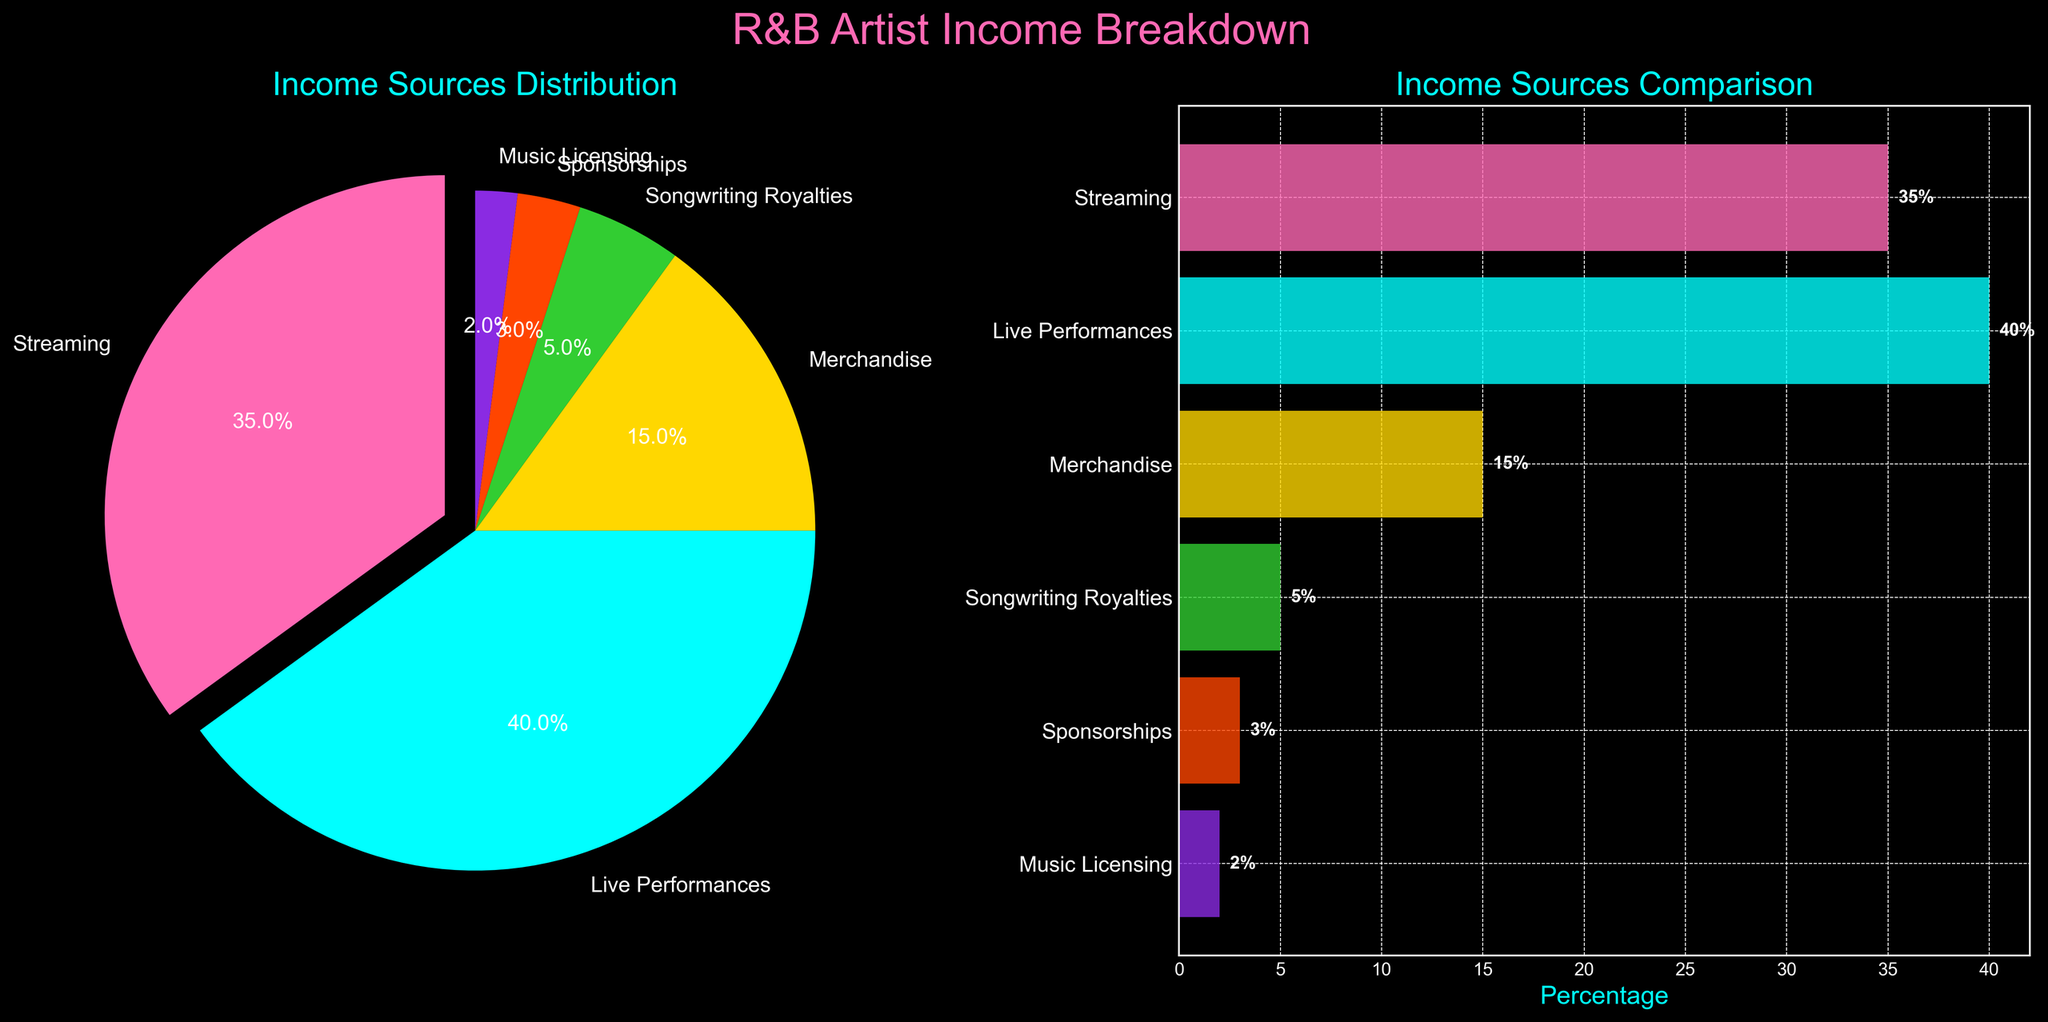What are the main income sources for R&B artists shown in the figure? The figure presents various income sources distributed in a pie chart and a horizontal bar chart. The main sources are Streaming, Live Performances, Merchandise, Songwriting Royalties, Sponsorships, and Music Licensing.
Answer: Streaming, Live Performances, Merchandise, Songwriting Royalties, Sponsorships, Music Licensing Which income source contributes the highest percentage to R&B artists' income? The pie chart and bar chart both show the highest percentage contribution from Live Performances.
Answer: Live Performances How does the income from Streaming compare to the income from Merchandise? By looking at the percentages in both charts, Streaming contributes 35%, while Merchandise contributes 15%.
Answer: Streaming is more than double Merchandise What is the combined percentage of income from Songwriting Royalties, Sponsorships, and Music Licensing? Add the percentages of these three sources: 5% (Songwriting Royalties) + 3% (Sponsorships) + 2% (Music Licensing) = 10%.
Answer: 10% Which two sources together almost equal the income from Live Performances? From the bar and pie charts, Streaming (35%) and Merchandise (15%) are closest to Live Performances (40%) when combined. Their total is 35% + 15% = 50%.
Answer: Streaming and Merchandise What percentage of income comes from sources other than Live Performances and Streaming? Subtract the percentages of Live Performances (40%) and Streaming (35%) from the total: 100% - 40% - 35% = 25%.
Answer: 25% Are Songwriting Royalties a smaller or larger income source than Merchandise? Both charts show Merchandise at 15% and Songwriting Royalties at 5%, indicating Songwriting Royalties is smaller.
Answer: Smaller What’s the difference in percentage between the largest and smallest income sources? The largest source is Live Performances (40%) and the smallest is Music Licensing (2%). The difference is 40% - 2% = 38%.
Answer: 38% How many income sources are depicted in the charts? Both charts display six different income sources.
Answer: Six 